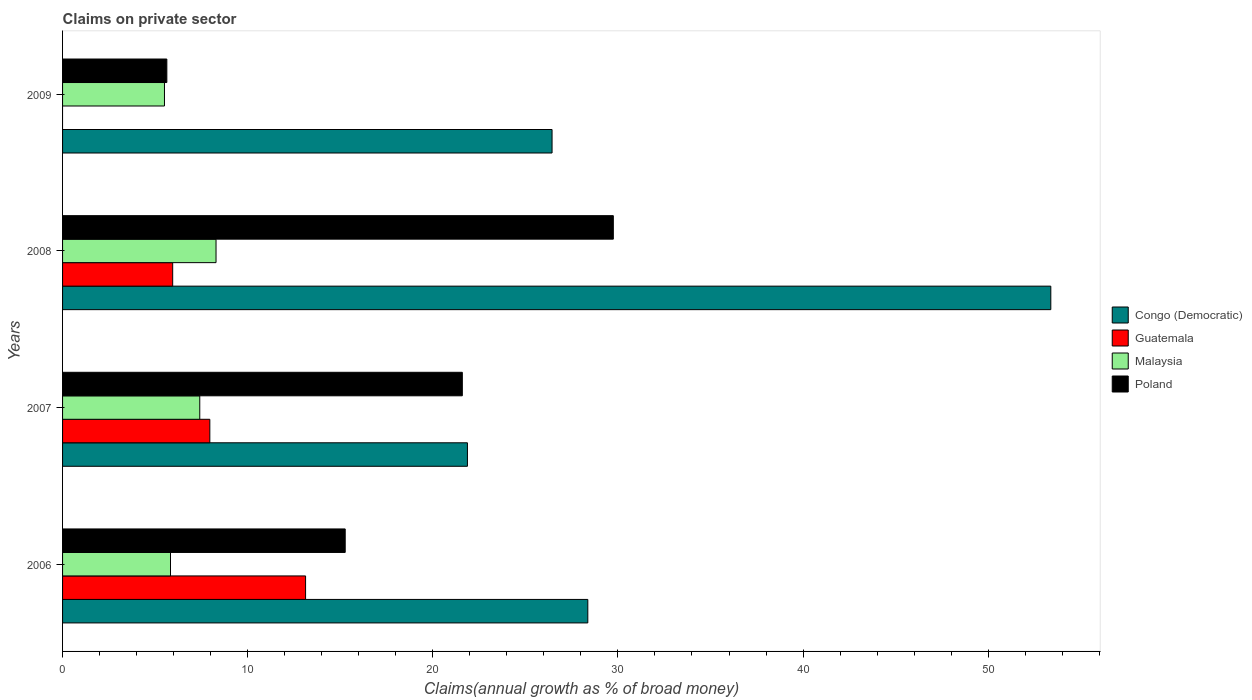How many different coloured bars are there?
Offer a terse response. 4. Are the number of bars on each tick of the Y-axis equal?
Your answer should be compact. No. How many bars are there on the 1st tick from the top?
Your response must be concise. 3. How many bars are there on the 3rd tick from the bottom?
Offer a terse response. 4. In how many cases, is the number of bars for a given year not equal to the number of legend labels?
Your answer should be very brief. 1. What is the percentage of broad money claimed on private sector in Poland in 2007?
Your response must be concise. 21.59. Across all years, what is the maximum percentage of broad money claimed on private sector in Malaysia?
Provide a short and direct response. 8.29. Across all years, what is the minimum percentage of broad money claimed on private sector in Poland?
Provide a short and direct response. 5.63. In which year was the percentage of broad money claimed on private sector in Poland maximum?
Make the answer very short. 2008. What is the total percentage of broad money claimed on private sector in Guatemala in the graph?
Your answer should be very brief. 27.03. What is the difference between the percentage of broad money claimed on private sector in Congo (Democratic) in 2007 and that in 2008?
Your answer should be compact. -31.51. What is the difference between the percentage of broad money claimed on private sector in Poland in 2009 and the percentage of broad money claimed on private sector in Congo (Democratic) in 2008?
Your response must be concise. -47.75. What is the average percentage of broad money claimed on private sector in Malaysia per year?
Provide a succinct answer. 6.76. In the year 2009, what is the difference between the percentage of broad money claimed on private sector in Malaysia and percentage of broad money claimed on private sector in Poland?
Give a very brief answer. -0.13. In how many years, is the percentage of broad money claimed on private sector in Guatemala greater than 34 %?
Your response must be concise. 0. What is the ratio of the percentage of broad money claimed on private sector in Congo (Democratic) in 2007 to that in 2008?
Offer a very short reply. 0.41. What is the difference between the highest and the second highest percentage of broad money claimed on private sector in Poland?
Ensure brevity in your answer.  8.16. What is the difference between the highest and the lowest percentage of broad money claimed on private sector in Guatemala?
Your response must be concise. 13.13. In how many years, is the percentage of broad money claimed on private sector in Congo (Democratic) greater than the average percentage of broad money claimed on private sector in Congo (Democratic) taken over all years?
Keep it short and to the point. 1. Is it the case that in every year, the sum of the percentage of broad money claimed on private sector in Poland and percentage of broad money claimed on private sector in Malaysia is greater than the percentage of broad money claimed on private sector in Congo (Democratic)?
Offer a terse response. No. How many bars are there?
Offer a very short reply. 15. What is the difference between two consecutive major ticks on the X-axis?
Ensure brevity in your answer.  10. Where does the legend appear in the graph?
Offer a terse response. Center right. How many legend labels are there?
Your answer should be very brief. 4. What is the title of the graph?
Make the answer very short. Claims on private sector. Does "Liechtenstein" appear as one of the legend labels in the graph?
Keep it short and to the point. No. What is the label or title of the X-axis?
Give a very brief answer. Claims(annual growth as % of broad money). What is the label or title of the Y-axis?
Ensure brevity in your answer.  Years. What is the Claims(annual growth as % of broad money) in Congo (Democratic) in 2006?
Make the answer very short. 28.37. What is the Claims(annual growth as % of broad money) in Guatemala in 2006?
Your answer should be compact. 13.13. What is the Claims(annual growth as % of broad money) in Malaysia in 2006?
Provide a succinct answer. 5.83. What is the Claims(annual growth as % of broad money) in Poland in 2006?
Your answer should be very brief. 15.27. What is the Claims(annual growth as % of broad money) in Congo (Democratic) in 2007?
Keep it short and to the point. 21.87. What is the Claims(annual growth as % of broad money) of Guatemala in 2007?
Offer a terse response. 7.96. What is the Claims(annual growth as % of broad money) in Malaysia in 2007?
Provide a succinct answer. 7.41. What is the Claims(annual growth as % of broad money) in Poland in 2007?
Your answer should be very brief. 21.59. What is the Claims(annual growth as % of broad money) in Congo (Democratic) in 2008?
Give a very brief answer. 53.38. What is the Claims(annual growth as % of broad money) of Guatemala in 2008?
Provide a succinct answer. 5.95. What is the Claims(annual growth as % of broad money) of Malaysia in 2008?
Offer a terse response. 8.29. What is the Claims(annual growth as % of broad money) of Poland in 2008?
Offer a very short reply. 29.75. What is the Claims(annual growth as % of broad money) in Congo (Democratic) in 2009?
Provide a short and direct response. 26.44. What is the Claims(annual growth as % of broad money) in Malaysia in 2009?
Give a very brief answer. 5.5. What is the Claims(annual growth as % of broad money) of Poland in 2009?
Make the answer very short. 5.63. Across all years, what is the maximum Claims(annual growth as % of broad money) in Congo (Democratic)?
Offer a very short reply. 53.38. Across all years, what is the maximum Claims(annual growth as % of broad money) in Guatemala?
Make the answer very short. 13.13. Across all years, what is the maximum Claims(annual growth as % of broad money) in Malaysia?
Keep it short and to the point. 8.29. Across all years, what is the maximum Claims(annual growth as % of broad money) in Poland?
Give a very brief answer. 29.75. Across all years, what is the minimum Claims(annual growth as % of broad money) of Congo (Democratic)?
Ensure brevity in your answer.  21.87. Across all years, what is the minimum Claims(annual growth as % of broad money) of Malaysia?
Provide a short and direct response. 5.5. Across all years, what is the minimum Claims(annual growth as % of broad money) in Poland?
Your response must be concise. 5.63. What is the total Claims(annual growth as % of broad money) in Congo (Democratic) in the graph?
Ensure brevity in your answer.  130.07. What is the total Claims(annual growth as % of broad money) of Guatemala in the graph?
Your answer should be compact. 27.03. What is the total Claims(annual growth as % of broad money) in Malaysia in the graph?
Ensure brevity in your answer.  27.04. What is the total Claims(annual growth as % of broad money) of Poland in the graph?
Keep it short and to the point. 72.25. What is the difference between the Claims(annual growth as % of broad money) in Congo (Democratic) in 2006 and that in 2007?
Ensure brevity in your answer.  6.5. What is the difference between the Claims(annual growth as % of broad money) in Guatemala in 2006 and that in 2007?
Ensure brevity in your answer.  5.17. What is the difference between the Claims(annual growth as % of broad money) in Malaysia in 2006 and that in 2007?
Provide a succinct answer. -1.58. What is the difference between the Claims(annual growth as % of broad money) in Poland in 2006 and that in 2007?
Provide a short and direct response. -6.33. What is the difference between the Claims(annual growth as % of broad money) in Congo (Democratic) in 2006 and that in 2008?
Provide a short and direct response. -25.01. What is the difference between the Claims(annual growth as % of broad money) in Guatemala in 2006 and that in 2008?
Your response must be concise. 7.18. What is the difference between the Claims(annual growth as % of broad money) of Malaysia in 2006 and that in 2008?
Keep it short and to the point. -2.46. What is the difference between the Claims(annual growth as % of broad money) in Poland in 2006 and that in 2008?
Provide a succinct answer. -14.48. What is the difference between the Claims(annual growth as % of broad money) of Congo (Democratic) in 2006 and that in 2009?
Keep it short and to the point. 1.93. What is the difference between the Claims(annual growth as % of broad money) of Malaysia in 2006 and that in 2009?
Provide a succinct answer. 0.33. What is the difference between the Claims(annual growth as % of broad money) of Poland in 2006 and that in 2009?
Your answer should be compact. 9.64. What is the difference between the Claims(annual growth as % of broad money) of Congo (Democratic) in 2007 and that in 2008?
Provide a succinct answer. -31.51. What is the difference between the Claims(annual growth as % of broad money) of Guatemala in 2007 and that in 2008?
Your answer should be compact. 2.01. What is the difference between the Claims(annual growth as % of broad money) in Malaysia in 2007 and that in 2008?
Provide a succinct answer. -0.88. What is the difference between the Claims(annual growth as % of broad money) of Poland in 2007 and that in 2008?
Offer a terse response. -8.16. What is the difference between the Claims(annual growth as % of broad money) in Congo (Democratic) in 2007 and that in 2009?
Provide a short and direct response. -4.57. What is the difference between the Claims(annual growth as % of broad money) in Malaysia in 2007 and that in 2009?
Ensure brevity in your answer.  1.91. What is the difference between the Claims(annual growth as % of broad money) of Poland in 2007 and that in 2009?
Your answer should be very brief. 15.96. What is the difference between the Claims(annual growth as % of broad money) in Congo (Democratic) in 2008 and that in 2009?
Your answer should be very brief. 26.94. What is the difference between the Claims(annual growth as % of broad money) in Malaysia in 2008 and that in 2009?
Keep it short and to the point. 2.79. What is the difference between the Claims(annual growth as % of broad money) in Poland in 2008 and that in 2009?
Provide a succinct answer. 24.12. What is the difference between the Claims(annual growth as % of broad money) in Congo (Democratic) in 2006 and the Claims(annual growth as % of broad money) in Guatemala in 2007?
Offer a very short reply. 20.42. What is the difference between the Claims(annual growth as % of broad money) of Congo (Democratic) in 2006 and the Claims(annual growth as % of broad money) of Malaysia in 2007?
Offer a very short reply. 20.96. What is the difference between the Claims(annual growth as % of broad money) in Congo (Democratic) in 2006 and the Claims(annual growth as % of broad money) in Poland in 2007?
Offer a terse response. 6.78. What is the difference between the Claims(annual growth as % of broad money) of Guatemala in 2006 and the Claims(annual growth as % of broad money) of Malaysia in 2007?
Your response must be concise. 5.72. What is the difference between the Claims(annual growth as % of broad money) of Guatemala in 2006 and the Claims(annual growth as % of broad money) of Poland in 2007?
Your answer should be compact. -8.47. What is the difference between the Claims(annual growth as % of broad money) of Malaysia in 2006 and the Claims(annual growth as % of broad money) of Poland in 2007?
Your response must be concise. -15.76. What is the difference between the Claims(annual growth as % of broad money) of Congo (Democratic) in 2006 and the Claims(annual growth as % of broad money) of Guatemala in 2008?
Offer a very short reply. 22.43. What is the difference between the Claims(annual growth as % of broad money) in Congo (Democratic) in 2006 and the Claims(annual growth as % of broad money) in Malaysia in 2008?
Offer a terse response. 20.08. What is the difference between the Claims(annual growth as % of broad money) in Congo (Democratic) in 2006 and the Claims(annual growth as % of broad money) in Poland in 2008?
Keep it short and to the point. -1.38. What is the difference between the Claims(annual growth as % of broad money) in Guatemala in 2006 and the Claims(annual growth as % of broad money) in Malaysia in 2008?
Keep it short and to the point. 4.84. What is the difference between the Claims(annual growth as % of broad money) of Guatemala in 2006 and the Claims(annual growth as % of broad money) of Poland in 2008?
Make the answer very short. -16.62. What is the difference between the Claims(annual growth as % of broad money) in Malaysia in 2006 and the Claims(annual growth as % of broad money) in Poland in 2008?
Offer a very short reply. -23.92. What is the difference between the Claims(annual growth as % of broad money) in Congo (Democratic) in 2006 and the Claims(annual growth as % of broad money) in Malaysia in 2009?
Make the answer very short. 22.87. What is the difference between the Claims(annual growth as % of broad money) in Congo (Democratic) in 2006 and the Claims(annual growth as % of broad money) in Poland in 2009?
Your answer should be very brief. 22.74. What is the difference between the Claims(annual growth as % of broad money) of Guatemala in 2006 and the Claims(annual growth as % of broad money) of Malaysia in 2009?
Make the answer very short. 7.62. What is the difference between the Claims(annual growth as % of broad money) of Guatemala in 2006 and the Claims(annual growth as % of broad money) of Poland in 2009?
Offer a terse response. 7.49. What is the difference between the Claims(annual growth as % of broad money) of Malaysia in 2006 and the Claims(annual growth as % of broad money) of Poland in 2009?
Provide a succinct answer. 0.2. What is the difference between the Claims(annual growth as % of broad money) in Congo (Democratic) in 2007 and the Claims(annual growth as % of broad money) in Guatemala in 2008?
Your response must be concise. 15.92. What is the difference between the Claims(annual growth as % of broad money) of Congo (Democratic) in 2007 and the Claims(annual growth as % of broad money) of Malaysia in 2008?
Give a very brief answer. 13.58. What is the difference between the Claims(annual growth as % of broad money) of Congo (Democratic) in 2007 and the Claims(annual growth as % of broad money) of Poland in 2008?
Give a very brief answer. -7.88. What is the difference between the Claims(annual growth as % of broad money) of Guatemala in 2007 and the Claims(annual growth as % of broad money) of Malaysia in 2008?
Keep it short and to the point. -0.34. What is the difference between the Claims(annual growth as % of broad money) in Guatemala in 2007 and the Claims(annual growth as % of broad money) in Poland in 2008?
Provide a short and direct response. -21.8. What is the difference between the Claims(annual growth as % of broad money) of Malaysia in 2007 and the Claims(annual growth as % of broad money) of Poland in 2008?
Your answer should be compact. -22.34. What is the difference between the Claims(annual growth as % of broad money) in Congo (Democratic) in 2007 and the Claims(annual growth as % of broad money) in Malaysia in 2009?
Keep it short and to the point. 16.37. What is the difference between the Claims(annual growth as % of broad money) of Congo (Democratic) in 2007 and the Claims(annual growth as % of broad money) of Poland in 2009?
Your response must be concise. 16.24. What is the difference between the Claims(annual growth as % of broad money) of Guatemala in 2007 and the Claims(annual growth as % of broad money) of Malaysia in 2009?
Your response must be concise. 2.45. What is the difference between the Claims(annual growth as % of broad money) in Guatemala in 2007 and the Claims(annual growth as % of broad money) in Poland in 2009?
Give a very brief answer. 2.32. What is the difference between the Claims(annual growth as % of broad money) in Malaysia in 2007 and the Claims(annual growth as % of broad money) in Poland in 2009?
Give a very brief answer. 1.78. What is the difference between the Claims(annual growth as % of broad money) in Congo (Democratic) in 2008 and the Claims(annual growth as % of broad money) in Malaysia in 2009?
Your response must be concise. 47.88. What is the difference between the Claims(annual growth as % of broad money) in Congo (Democratic) in 2008 and the Claims(annual growth as % of broad money) in Poland in 2009?
Keep it short and to the point. 47.75. What is the difference between the Claims(annual growth as % of broad money) of Guatemala in 2008 and the Claims(annual growth as % of broad money) of Malaysia in 2009?
Ensure brevity in your answer.  0.44. What is the difference between the Claims(annual growth as % of broad money) of Guatemala in 2008 and the Claims(annual growth as % of broad money) of Poland in 2009?
Your response must be concise. 0.32. What is the difference between the Claims(annual growth as % of broad money) of Malaysia in 2008 and the Claims(annual growth as % of broad money) of Poland in 2009?
Provide a short and direct response. 2.66. What is the average Claims(annual growth as % of broad money) of Congo (Democratic) per year?
Your answer should be compact. 32.52. What is the average Claims(annual growth as % of broad money) of Guatemala per year?
Your response must be concise. 6.76. What is the average Claims(annual growth as % of broad money) of Malaysia per year?
Make the answer very short. 6.76. What is the average Claims(annual growth as % of broad money) in Poland per year?
Your answer should be very brief. 18.06. In the year 2006, what is the difference between the Claims(annual growth as % of broad money) of Congo (Democratic) and Claims(annual growth as % of broad money) of Guatemala?
Provide a succinct answer. 15.25. In the year 2006, what is the difference between the Claims(annual growth as % of broad money) of Congo (Democratic) and Claims(annual growth as % of broad money) of Malaysia?
Offer a terse response. 22.54. In the year 2006, what is the difference between the Claims(annual growth as % of broad money) in Congo (Democratic) and Claims(annual growth as % of broad money) in Poland?
Keep it short and to the point. 13.11. In the year 2006, what is the difference between the Claims(annual growth as % of broad money) in Guatemala and Claims(annual growth as % of broad money) in Malaysia?
Your answer should be compact. 7.3. In the year 2006, what is the difference between the Claims(annual growth as % of broad money) in Guatemala and Claims(annual growth as % of broad money) in Poland?
Provide a short and direct response. -2.14. In the year 2006, what is the difference between the Claims(annual growth as % of broad money) of Malaysia and Claims(annual growth as % of broad money) of Poland?
Keep it short and to the point. -9.44. In the year 2007, what is the difference between the Claims(annual growth as % of broad money) of Congo (Democratic) and Claims(annual growth as % of broad money) of Guatemala?
Keep it short and to the point. 13.92. In the year 2007, what is the difference between the Claims(annual growth as % of broad money) in Congo (Democratic) and Claims(annual growth as % of broad money) in Malaysia?
Your answer should be compact. 14.46. In the year 2007, what is the difference between the Claims(annual growth as % of broad money) of Congo (Democratic) and Claims(annual growth as % of broad money) of Poland?
Offer a very short reply. 0.28. In the year 2007, what is the difference between the Claims(annual growth as % of broad money) of Guatemala and Claims(annual growth as % of broad money) of Malaysia?
Make the answer very short. 0.54. In the year 2007, what is the difference between the Claims(annual growth as % of broad money) in Guatemala and Claims(annual growth as % of broad money) in Poland?
Your response must be concise. -13.64. In the year 2007, what is the difference between the Claims(annual growth as % of broad money) of Malaysia and Claims(annual growth as % of broad money) of Poland?
Make the answer very short. -14.18. In the year 2008, what is the difference between the Claims(annual growth as % of broad money) of Congo (Democratic) and Claims(annual growth as % of broad money) of Guatemala?
Provide a short and direct response. 47.44. In the year 2008, what is the difference between the Claims(annual growth as % of broad money) in Congo (Democratic) and Claims(annual growth as % of broad money) in Malaysia?
Offer a terse response. 45.09. In the year 2008, what is the difference between the Claims(annual growth as % of broad money) of Congo (Democratic) and Claims(annual growth as % of broad money) of Poland?
Ensure brevity in your answer.  23.63. In the year 2008, what is the difference between the Claims(annual growth as % of broad money) of Guatemala and Claims(annual growth as % of broad money) of Malaysia?
Ensure brevity in your answer.  -2.34. In the year 2008, what is the difference between the Claims(annual growth as % of broad money) of Guatemala and Claims(annual growth as % of broad money) of Poland?
Ensure brevity in your answer.  -23.8. In the year 2008, what is the difference between the Claims(annual growth as % of broad money) of Malaysia and Claims(annual growth as % of broad money) of Poland?
Offer a very short reply. -21.46. In the year 2009, what is the difference between the Claims(annual growth as % of broad money) of Congo (Democratic) and Claims(annual growth as % of broad money) of Malaysia?
Ensure brevity in your answer.  20.94. In the year 2009, what is the difference between the Claims(annual growth as % of broad money) of Congo (Democratic) and Claims(annual growth as % of broad money) of Poland?
Ensure brevity in your answer.  20.81. In the year 2009, what is the difference between the Claims(annual growth as % of broad money) of Malaysia and Claims(annual growth as % of broad money) of Poland?
Your answer should be compact. -0.13. What is the ratio of the Claims(annual growth as % of broad money) in Congo (Democratic) in 2006 to that in 2007?
Your response must be concise. 1.3. What is the ratio of the Claims(annual growth as % of broad money) in Guatemala in 2006 to that in 2007?
Offer a terse response. 1.65. What is the ratio of the Claims(annual growth as % of broad money) of Malaysia in 2006 to that in 2007?
Give a very brief answer. 0.79. What is the ratio of the Claims(annual growth as % of broad money) in Poland in 2006 to that in 2007?
Your answer should be compact. 0.71. What is the ratio of the Claims(annual growth as % of broad money) of Congo (Democratic) in 2006 to that in 2008?
Your response must be concise. 0.53. What is the ratio of the Claims(annual growth as % of broad money) in Guatemala in 2006 to that in 2008?
Make the answer very short. 2.21. What is the ratio of the Claims(annual growth as % of broad money) in Malaysia in 2006 to that in 2008?
Ensure brevity in your answer.  0.7. What is the ratio of the Claims(annual growth as % of broad money) in Poland in 2006 to that in 2008?
Make the answer very short. 0.51. What is the ratio of the Claims(annual growth as % of broad money) of Congo (Democratic) in 2006 to that in 2009?
Your answer should be compact. 1.07. What is the ratio of the Claims(annual growth as % of broad money) in Malaysia in 2006 to that in 2009?
Provide a succinct answer. 1.06. What is the ratio of the Claims(annual growth as % of broad money) of Poland in 2006 to that in 2009?
Your answer should be very brief. 2.71. What is the ratio of the Claims(annual growth as % of broad money) in Congo (Democratic) in 2007 to that in 2008?
Provide a short and direct response. 0.41. What is the ratio of the Claims(annual growth as % of broad money) of Guatemala in 2007 to that in 2008?
Offer a terse response. 1.34. What is the ratio of the Claims(annual growth as % of broad money) in Malaysia in 2007 to that in 2008?
Make the answer very short. 0.89. What is the ratio of the Claims(annual growth as % of broad money) of Poland in 2007 to that in 2008?
Your answer should be compact. 0.73. What is the ratio of the Claims(annual growth as % of broad money) in Congo (Democratic) in 2007 to that in 2009?
Keep it short and to the point. 0.83. What is the ratio of the Claims(annual growth as % of broad money) in Malaysia in 2007 to that in 2009?
Your response must be concise. 1.35. What is the ratio of the Claims(annual growth as % of broad money) of Poland in 2007 to that in 2009?
Your answer should be very brief. 3.83. What is the ratio of the Claims(annual growth as % of broad money) of Congo (Democratic) in 2008 to that in 2009?
Make the answer very short. 2.02. What is the ratio of the Claims(annual growth as % of broad money) of Malaysia in 2008 to that in 2009?
Make the answer very short. 1.51. What is the ratio of the Claims(annual growth as % of broad money) of Poland in 2008 to that in 2009?
Ensure brevity in your answer.  5.28. What is the difference between the highest and the second highest Claims(annual growth as % of broad money) of Congo (Democratic)?
Offer a terse response. 25.01. What is the difference between the highest and the second highest Claims(annual growth as % of broad money) of Guatemala?
Keep it short and to the point. 5.17. What is the difference between the highest and the second highest Claims(annual growth as % of broad money) of Malaysia?
Your answer should be compact. 0.88. What is the difference between the highest and the second highest Claims(annual growth as % of broad money) in Poland?
Provide a short and direct response. 8.16. What is the difference between the highest and the lowest Claims(annual growth as % of broad money) in Congo (Democratic)?
Offer a very short reply. 31.51. What is the difference between the highest and the lowest Claims(annual growth as % of broad money) of Guatemala?
Make the answer very short. 13.13. What is the difference between the highest and the lowest Claims(annual growth as % of broad money) of Malaysia?
Offer a terse response. 2.79. What is the difference between the highest and the lowest Claims(annual growth as % of broad money) of Poland?
Your answer should be compact. 24.12. 